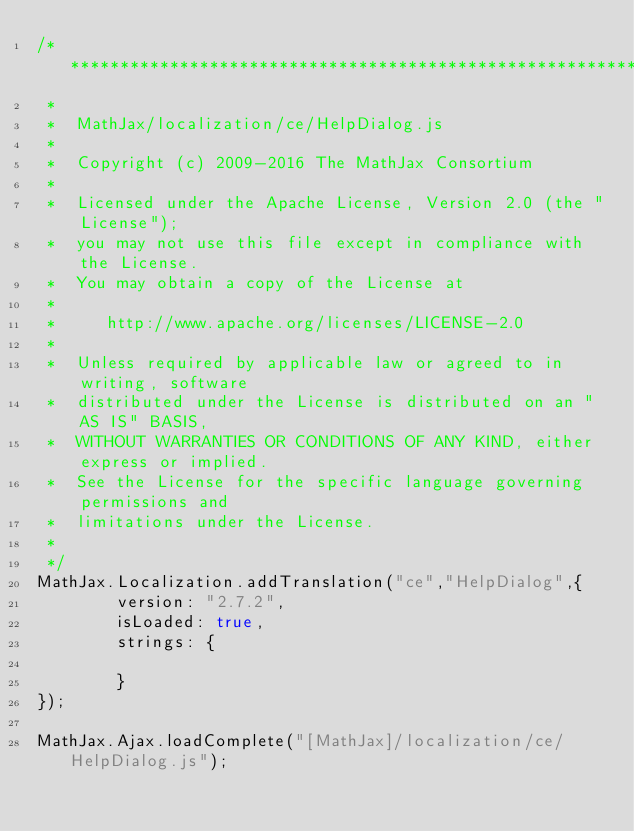<code> <loc_0><loc_0><loc_500><loc_500><_JavaScript_>/*************************************************************
 *
 *  MathJax/localization/ce/HelpDialog.js
 *
 *  Copyright (c) 2009-2016 The MathJax Consortium
 *
 *  Licensed under the Apache License, Version 2.0 (the "License");
 *  you may not use this file except in compliance with the License.
 *  You may obtain a copy of the License at
 *
 *     http://www.apache.org/licenses/LICENSE-2.0
 *
 *  Unless required by applicable law or agreed to in writing, software
 *  distributed under the License is distributed on an "AS IS" BASIS,
 *  WITHOUT WARRANTIES OR CONDITIONS OF ANY KIND, either express or implied.
 *  See the License for the specific language governing permissions and
 *  limitations under the License.
 *
 */
MathJax.Localization.addTranslation("ce","HelpDialog",{
        version: "2.7.2",
        isLoaded: true,
        strings: {

        }
});

MathJax.Ajax.loadComplete("[MathJax]/localization/ce/HelpDialog.js");
</code> 